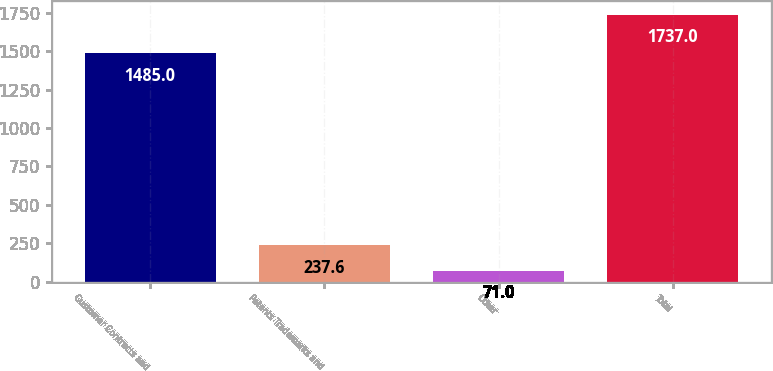Convert chart to OTSL. <chart><loc_0><loc_0><loc_500><loc_500><bar_chart><fcel>Customer Contracts and<fcel>Patents Trademarks and<fcel>Other<fcel>Total<nl><fcel>1485<fcel>237.6<fcel>71<fcel>1737<nl></chart> 